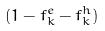Convert formula to latex. <formula><loc_0><loc_0><loc_500><loc_500>( 1 - f _ { k } ^ { e } - f _ { k } ^ { h } )</formula> 